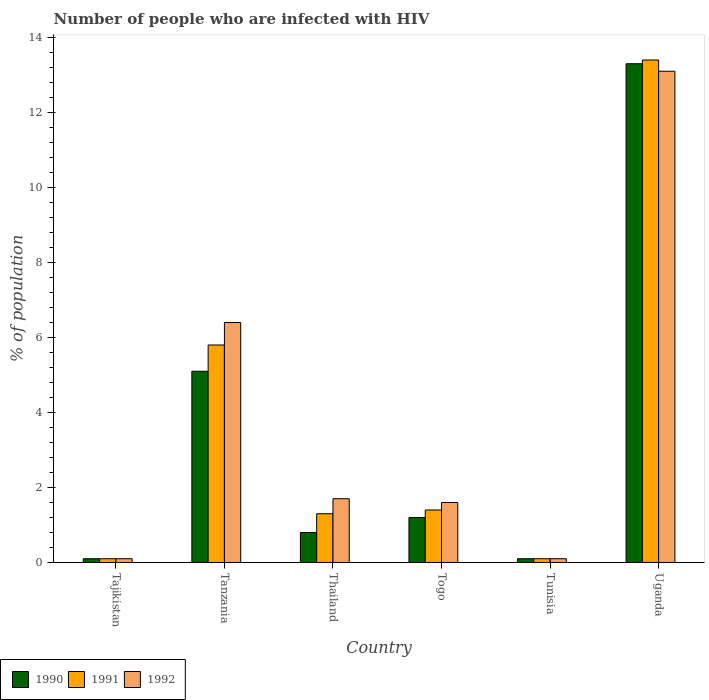How many groups of bars are there?
Provide a succinct answer. 6. How many bars are there on the 5th tick from the left?
Your response must be concise. 3. What is the label of the 4th group of bars from the left?
Your answer should be compact. Togo. What is the percentage of HIV infected population in in 1990 in Tanzania?
Your answer should be very brief. 5.1. Across all countries, what is the maximum percentage of HIV infected population in in 1992?
Provide a short and direct response. 13.1. Across all countries, what is the minimum percentage of HIV infected population in in 1991?
Keep it short and to the point. 0.1. In which country was the percentage of HIV infected population in in 1992 maximum?
Your answer should be compact. Uganda. In which country was the percentage of HIV infected population in in 1990 minimum?
Offer a very short reply. Tajikistan. What is the total percentage of HIV infected population in in 1991 in the graph?
Give a very brief answer. 22.1. What is the difference between the percentage of HIV infected population in in 1992 in Tanzania and that in Thailand?
Provide a succinct answer. 4.7. What is the average percentage of HIV infected population in in 1992 per country?
Your answer should be very brief. 3.83. What is the ratio of the percentage of HIV infected population in in 1992 in Togo to that in Uganda?
Offer a very short reply. 0.12. Is the percentage of HIV infected population in in 1991 in Tanzania less than that in Togo?
Your response must be concise. No. What is the difference between the highest and the lowest percentage of HIV infected population in in 1991?
Offer a very short reply. 13.3. Is the sum of the percentage of HIV infected population in in 1992 in Thailand and Togo greater than the maximum percentage of HIV infected population in in 1991 across all countries?
Give a very brief answer. No. Is it the case that in every country, the sum of the percentage of HIV infected population in in 1990 and percentage of HIV infected population in in 1991 is greater than the percentage of HIV infected population in in 1992?
Provide a short and direct response. Yes. Are the values on the major ticks of Y-axis written in scientific E-notation?
Keep it short and to the point. No. Does the graph contain any zero values?
Ensure brevity in your answer.  No. Does the graph contain grids?
Ensure brevity in your answer.  No. What is the title of the graph?
Offer a terse response. Number of people who are infected with HIV. What is the label or title of the X-axis?
Provide a short and direct response. Country. What is the label or title of the Y-axis?
Offer a very short reply. % of population. What is the % of population in 1990 in Tajikistan?
Give a very brief answer. 0.1. What is the % of population in 1991 in Tajikistan?
Your answer should be compact. 0.1. What is the % of population of 1990 in Tanzania?
Give a very brief answer. 5.1. What is the % of population of 1991 in Tanzania?
Ensure brevity in your answer.  5.8. What is the % of population in 1992 in Thailand?
Provide a short and direct response. 1.7. What is the % of population in 1990 in Togo?
Your answer should be very brief. 1.2. What is the % of population of 1991 in Togo?
Make the answer very short. 1.4. Across all countries, what is the maximum % of population in 1991?
Give a very brief answer. 13.4. Across all countries, what is the maximum % of population of 1992?
Your answer should be compact. 13.1. Across all countries, what is the minimum % of population of 1990?
Provide a short and direct response. 0.1. Across all countries, what is the minimum % of population in 1992?
Provide a succinct answer. 0.1. What is the total % of population of 1990 in the graph?
Offer a terse response. 20.6. What is the total % of population in 1991 in the graph?
Offer a very short reply. 22.1. What is the difference between the % of population in 1990 in Tajikistan and that in Tanzania?
Make the answer very short. -5. What is the difference between the % of population in 1991 in Tajikistan and that in Tanzania?
Your answer should be compact. -5.7. What is the difference between the % of population of 1991 in Tajikistan and that in Thailand?
Provide a succinct answer. -1.2. What is the difference between the % of population in 1992 in Tajikistan and that in Thailand?
Offer a terse response. -1.6. What is the difference between the % of population in 1990 in Tajikistan and that in Tunisia?
Your answer should be very brief. 0. What is the difference between the % of population of 1991 in Tajikistan and that in Tunisia?
Your response must be concise. 0. What is the difference between the % of population of 1992 in Tajikistan and that in Tunisia?
Your response must be concise. 0. What is the difference between the % of population of 1990 in Tajikistan and that in Uganda?
Make the answer very short. -13.2. What is the difference between the % of population in 1991 in Tajikistan and that in Uganda?
Your response must be concise. -13.3. What is the difference between the % of population of 1992 in Tajikistan and that in Uganda?
Provide a short and direct response. -13. What is the difference between the % of population in 1990 in Tanzania and that in Thailand?
Provide a short and direct response. 4.3. What is the difference between the % of population in 1992 in Tanzania and that in Thailand?
Give a very brief answer. 4.7. What is the difference between the % of population of 1990 in Tanzania and that in Togo?
Ensure brevity in your answer.  3.9. What is the difference between the % of population in 1991 in Tanzania and that in Togo?
Give a very brief answer. 4.4. What is the difference between the % of population of 1992 in Tanzania and that in Togo?
Offer a terse response. 4.8. What is the difference between the % of population in 1990 in Tanzania and that in Tunisia?
Make the answer very short. 5. What is the difference between the % of population in 1991 in Tanzania and that in Tunisia?
Give a very brief answer. 5.7. What is the difference between the % of population of 1992 in Tanzania and that in Tunisia?
Your answer should be very brief. 6.3. What is the difference between the % of population in 1990 in Tanzania and that in Uganda?
Give a very brief answer. -8.2. What is the difference between the % of population in 1991 in Tanzania and that in Uganda?
Your response must be concise. -7.6. What is the difference between the % of population in 1992 in Tanzania and that in Uganda?
Provide a succinct answer. -6.7. What is the difference between the % of population in 1991 in Thailand and that in Togo?
Your answer should be very brief. -0.1. What is the difference between the % of population of 1991 in Thailand and that in Tunisia?
Your response must be concise. 1.2. What is the difference between the % of population in 1990 in Thailand and that in Uganda?
Offer a very short reply. -12.5. What is the difference between the % of population of 1991 in Thailand and that in Uganda?
Your answer should be compact. -12.1. What is the difference between the % of population in 1992 in Thailand and that in Uganda?
Your answer should be compact. -11.4. What is the difference between the % of population of 1990 in Togo and that in Tunisia?
Offer a terse response. 1.1. What is the difference between the % of population in 1991 in Togo and that in Tunisia?
Provide a succinct answer. 1.3. What is the difference between the % of population in 1992 in Togo and that in Tunisia?
Provide a short and direct response. 1.5. What is the difference between the % of population in 1990 in Togo and that in Uganda?
Your answer should be very brief. -12.1. What is the difference between the % of population of 1992 in Tunisia and that in Uganda?
Ensure brevity in your answer.  -13. What is the difference between the % of population of 1990 in Tajikistan and the % of population of 1991 in Thailand?
Ensure brevity in your answer.  -1.2. What is the difference between the % of population of 1991 in Tajikistan and the % of population of 1992 in Thailand?
Make the answer very short. -1.6. What is the difference between the % of population in 1990 in Tajikistan and the % of population in 1991 in Togo?
Provide a succinct answer. -1.3. What is the difference between the % of population of 1991 in Tajikistan and the % of population of 1992 in Tunisia?
Your response must be concise. 0. What is the difference between the % of population in 1990 in Tanzania and the % of population in 1992 in Thailand?
Your answer should be very brief. 3.4. What is the difference between the % of population of 1991 in Tanzania and the % of population of 1992 in Thailand?
Your response must be concise. 4.1. What is the difference between the % of population in 1990 in Tanzania and the % of population in 1991 in Togo?
Give a very brief answer. 3.7. What is the difference between the % of population of 1990 in Tanzania and the % of population of 1992 in Togo?
Ensure brevity in your answer.  3.5. What is the difference between the % of population in 1991 in Tanzania and the % of population in 1992 in Togo?
Keep it short and to the point. 4.2. What is the difference between the % of population in 1990 in Tanzania and the % of population in 1991 in Tunisia?
Give a very brief answer. 5. What is the difference between the % of population of 1990 in Tanzania and the % of population of 1992 in Tunisia?
Ensure brevity in your answer.  5. What is the difference between the % of population in 1991 in Tanzania and the % of population in 1992 in Uganda?
Provide a succinct answer. -7.3. What is the difference between the % of population of 1990 in Thailand and the % of population of 1991 in Togo?
Provide a short and direct response. -0.6. What is the difference between the % of population of 1990 in Thailand and the % of population of 1992 in Tunisia?
Provide a short and direct response. 0.7. What is the difference between the % of population in 1991 in Thailand and the % of population in 1992 in Tunisia?
Provide a succinct answer. 1.2. What is the difference between the % of population in 1991 in Thailand and the % of population in 1992 in Uganda?
Provide a succinct answer. -11.8. What is the difference between the % of population of 1991 in Togo and the % of population of 1992 in Tunisia?
Your answer should be very brief. 1.3. What is the difference between the % of population of 1990 in Togo and the % of population of 1992 in Uganda?
Offer a terse response. -11.9. What is the difference between the % of population in 1991 in Tunisia and the % of population in 1992 in Uganda?
Offer a terse response. -13. What is the average % of population in 1990 per country?
Offer a very short reply. 3.43. What is the average % of population of 1991 per country?
Your answer should be compact. 3.68. What is the average % of population of 1992 per country?
Keep it short and to the point. 3.83. What is the difference between the % of population of 1991 and % of population of 1992 in Tanzania?
Offer a very short reply. -0.6. What is the difference between the % of population in 1990 and % of population in 1991 in Thailand?
Give a very brief answer. -0.5. What is the difference between the % of population of 1990 and % of population of 1992 in Thailand?
Provide a succinct answer. -0.9. What is the difference between the % of population of 1991 and % of population of 1992 in Thailand?
Ensure brevity in your answer.  -0.4. What is the difference between the % of population of 1990 and % of population of 1991 in Togo?
Give a very brief answer. -0.2. What is the difference between the % of population in 1991 and % of population in 1992 in Togo?
Keep it short and to the point. -0.2. What is the difference between the % of population of 1990 and % of population of 1991 in Tunisia?
Ensure brevity in your answer.  0. What is the difference between the % of population of 1990 and % of population of 1992 in Tunisia?
Give a very brief answer. 0. What is the difference between the % of population in 1991 and % of population in 1992 in Tunisia?
Keep it short and to the point. 0. What is the difference between the % of population of 1990 and % of population of 1991 in Uganda?
Ensure brevity in your answer.  -0.1. What is the difference between the % of population of 1990 and % of population of 1992 in Uganda?
Give a very brief answer. 0.2. What is the ratio of the % of population of 1990 in Tajikistan to that in Tanzania?
Make the answer very short. 0.02. What is the ratio of the % of population in 1991 in Tajikistan to that in Tanzania?
Your answer should be very brief. 0.02. What is the ratio of the % of population of 1992 in Tajikistan to that in Tanzania?
Provide a short and direct response. 0.02. What is the ratio of the % of population of 1991 in Tajikistan to that in Thailand?
Keep it short and to the point. 0.08. What is the ratio of the % of population of 1992 in Tajikistan to that in Thailand?
Make the answer very short. 0.06. What is the ratio of the % of population of 1990 in Tajikistan to that in Togo?
Make the answer very short. 0.08. What is the ratio of the % of population of 1991 in Tajikistan to that in Togo?
Keep it short and to the point. 0.07. What is the ratio of the % of population in 1992 in Tajikistan to that in Togo?
Ensure brevity in your answer.  0.06. What is the ratio of the % of population of 1990 in Tajikistan to that in Tunisia?
Your response must be concise. 1. What is the ratio of the % of population of 1991 in Tajikistan to that in Tunisia?
Your response must be concise. 1. What is the ratio of the % of population in 1990 in Tajikistan to that in Uganda?
Provide a succinct answer. 0.01. What is the ratio of the % of population of 1991 in Tajikistan to that in Uganda?
Your answer should be compact. 0.01. What is the ratio of the % of population of 1992 in Tajikistan to that in Uganda?
Provide a short and direct response. 0.01. What is the ratio of the % of population of 1990 in Tanzania to that in Thailand?
Ensure brevity in your answer.  6.38. What is the ratio of the % of population of 1991 in Tanzania to that in Thailand?
Ensure brevity in your answer.  4.46. What is the ratio of the % of population of 1992 in Tanzania to that in Thailand?
Offer a terse response. 3.76. What is the ratio of the % of population in 1990 in Tanzania to that in Togo?
Make the answer very short. 4.25. What is the ratio of the % of population of 1991 in Tanzania to that in Togo?
Keep it short and to the point. 4.14. What is the ratio of the % of population in 1992 in Tanzania to that in Togo?
Keep it short and to the point. 4. What is the ratio of the % of population of 1990 in Tanzania to that in Tunisia?
Your response must be concise. 51. What is the ratio of the % of population in 1992 in Tanzania to that in Tunisia?
Make the answer very short. 64. What is the ratio of the % of population of 1990 in Tanzania to that in Uganda?
Offer a very short reply. 0.38. What is the ratio of the % of population in 1991 in Tanzania to that in Uganda?
Ensure brevity in your answer.  0.43. What is the ratio of the % of population of 1992 in Tanzania to that in Uganda?
Offer a terse response. 0.49. What is the ratio of the % of population of 1990 in Thailand to that in Togo?
Make the answer very short. 0.67. What is the ratio of the % of population in 1990 in Thailand to that in Tunisia?
Offer a very short reply. 8. What is the ratio of the % of population in 1991 in Thailand to that in Tunisia?
Make the answer very short. 13. What is the ratio of the % of population in 1990 in Thailand to that in Uganda?
Provide a short and direct response. 0.06. What is the ratio of the % of population of 1991 in Thailand to that in Uganda?
Provide a short and direct response. 0.1. What is the ratio of the % of population of 1992 in Thailand to that in Uganda?
Offer a very short reply. 0.13. What is the ratio of the % of population of 1990 in Togo to that in Uganda?
Your answer should be very brief. 0.09. What is the ratio of the % of population in 1991 in Togo to that in Uganda?
Offer a very short reply. 0.1. What is the ratio of the % of population in 1992 in Togo to that in Uganda?
Provide a short and direct response. 0.12. What is the ratio of the % of population in 1990 in Tunisia to that in Uganda?
Make the answer very short. 0.01. What is the ratio of the % of population in 1991 in Tunisia to that in Uganda?
Make the answer very short. 0.01. What is the ratio of the % of population in 1992 in Tunisia to that in Uganda?
Ensure brevity in your answer.  0.01. What is the difference between the highest and the second highest % of population in 1990?
Offer a very short reply. 8.2. What is the difference between the highest and the second highest % of population in 1992?
Give a very brief answer. 6.7. 